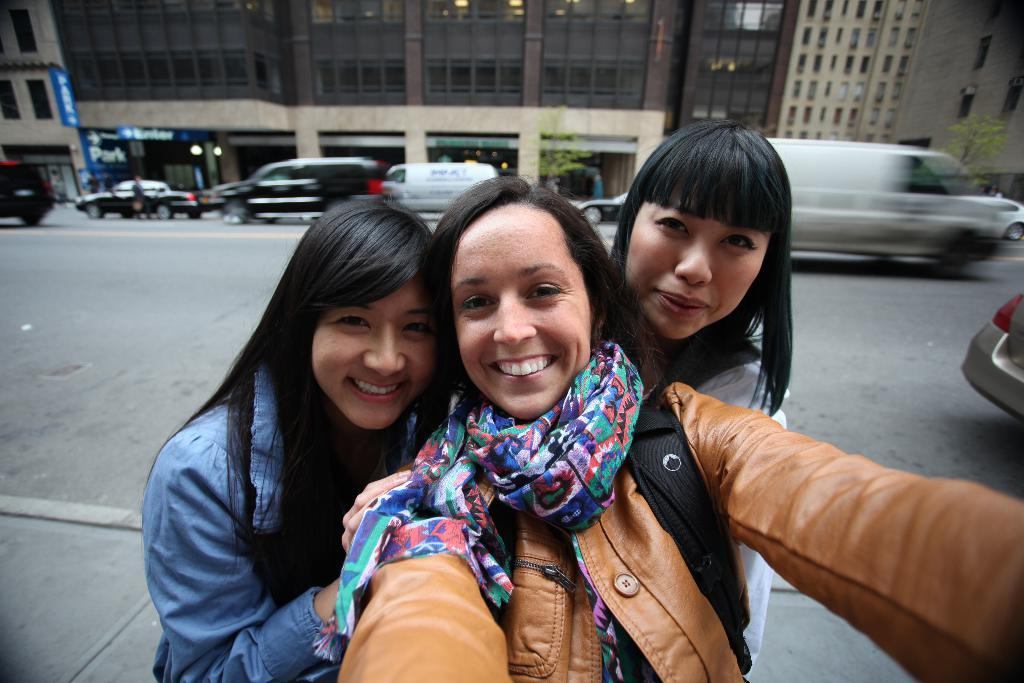How many people are in the image? There are three girls in the image. What are the girls doing in the image? The girls are taking a selfie. What can be seen in the background of the image? There is a road with vehicles and buildings with glass windows in the background of the image. Can you see the mother of the girls in the image? There is no mother present in the image; it only shows the three girls taking a selfie. 